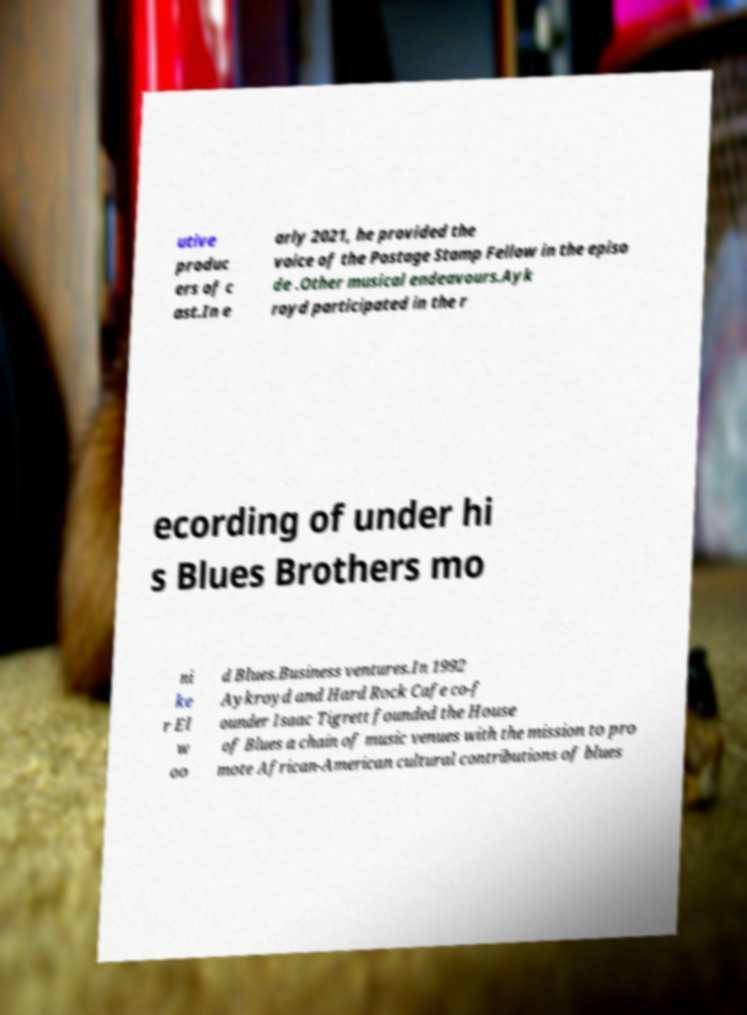Can you accurately transcribe the text from the provided image for me? utive produc ers of c ast.In e arly 2021, he provided the voice of the Postage Stamp Fellow in the episo de .Other musical endeavours.Ayk royd participated in the r ecording of under hi s Blues Brothers mo ni ke r El w oo d Blues.Business ventures.In 1992 Aykroyd and Hard Rock Cafe co-f ounder Isaac Tigrett founded the House of Blues a chain of music venues with the mission to pro mote African-American cultural contributions of blues 